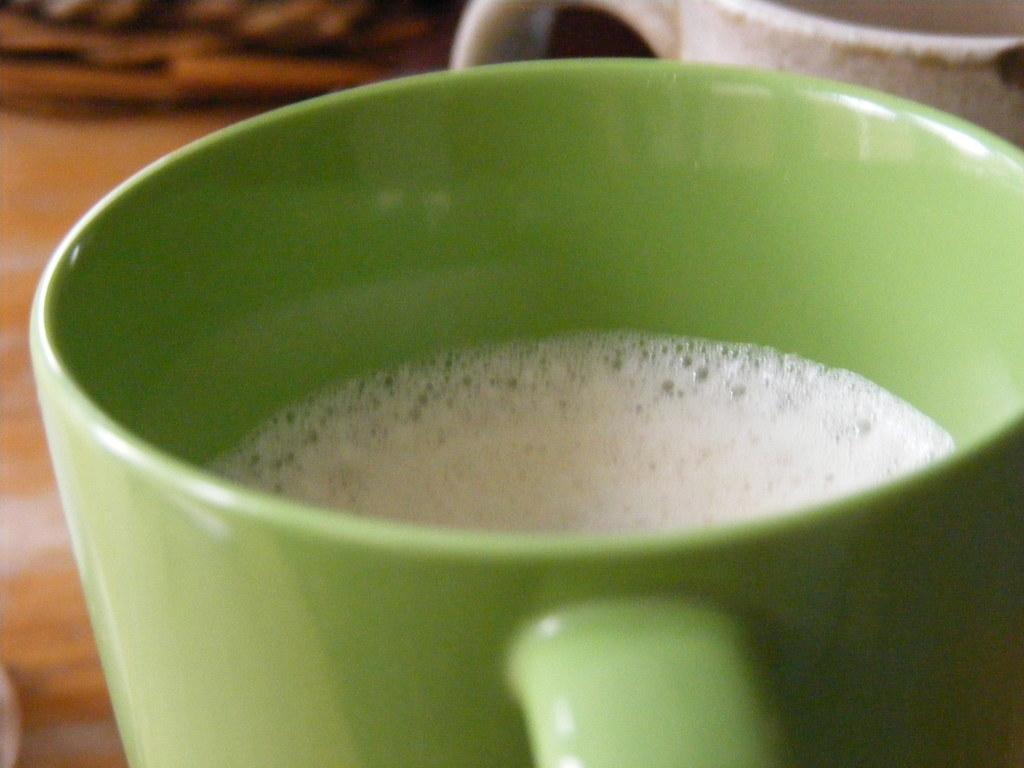What is the main object in the center of the image? There is a table in the center of the image. What items are placed on the table? There are two coffee mugs on the table. Can you describe the appearance of the coffee mugs? One coffee mug is green, and the other is white. What is in the green coffee mug? There is coffee in the green mug. What type of gun is visible on the table in the image? There is no gun present in the image; the table only has two coffee mugs on it. 